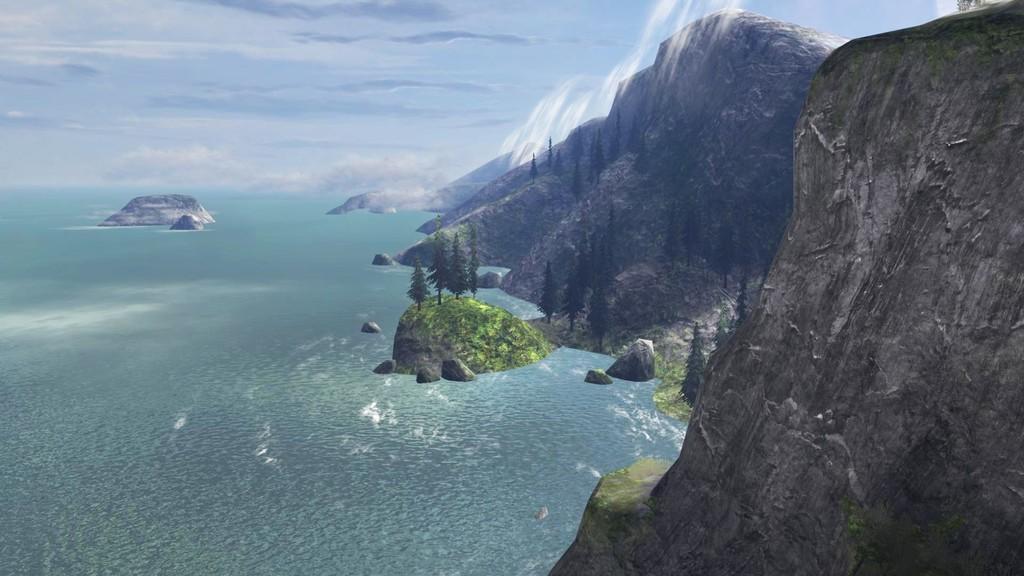In one or two sentences, can you explain what this image depicts? This picture looks like animated. On the right I can see the stone mountains. In the center I can see some trees and stones. On the left I can see the ocean. At the top I can see the sky and clouds. 